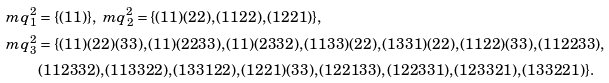Convert formula to latex. <formula><loc_0><loc_0><loc_500><loc_500>\ m q _ { 1 } ^ { 2 } & = \{ ( 1 1 ) \} , \ m q _ { 2 } ^ { 2 } = \{ ( 1 1 ) ( 2 2 ) , ( 1 1 2 2 ) , ( 1 2 2 1 ) \} , \\ \ m q _ { 3 } ^ { 2 } & = \{ ( 1 1 ) ( 2 2 ) ( 3 3 ) , ( 1 1 ) ( 2 2 3 3 ) , ( 1 1 ) ( 2 3 3 2 ) , ( 1 1 3 3 ) ( 2 2 ) , ( 1 3 3 1 ) ( 2 2 ) , ( 1 1 2 2 ) ( 3 3 ) , ( 1 1 2 2 3 3 ) , \\ & ( 1 1 2 3 3 2 ) , ( 1 1 3 3 2 2 ) , ( 1 3 3 1 2 2 ) , ( 1 2 2 1 ) ( 3 3 ) , ( 1 2 2 1 3 3 ) , ( 1 2 2 3 3 1 ) , ( 1 2 3 3 2 1 ) , ( 1 3 3 2 2 1 ) \} .</formula> 